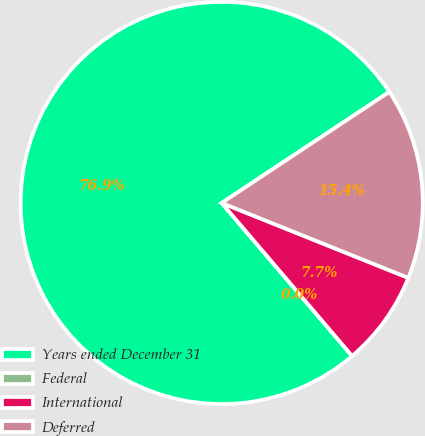Convert chart. <chart><loc_0><loc_0><loc_500><loc_500><pie_chart><fcel>Years ended December 31<fcel>Federal<fcel>International<fcel>Deferred<nl><fcel>76.92%<fcel>0.0%<fcel>7.69%<fcel>15.39%<nl></chart> 